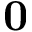<formula> <loc_0><loc_0><loc_500><loc_500>{ 0 }</formula> 